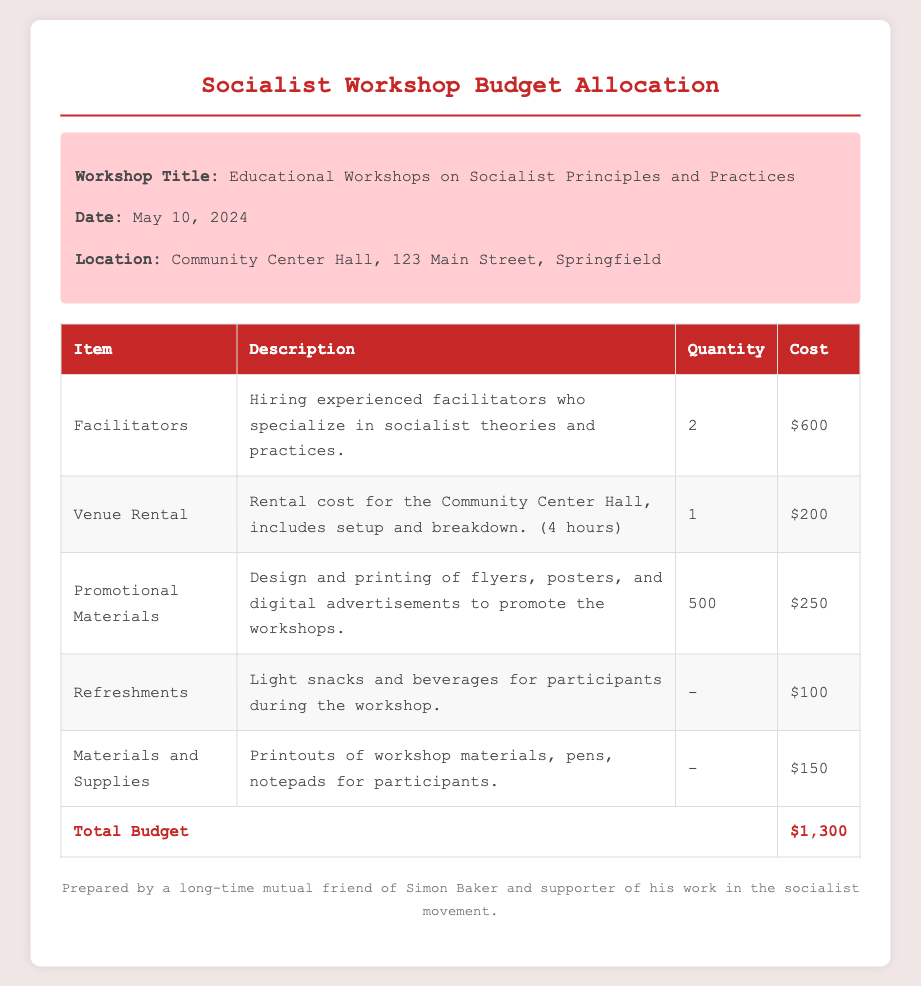What is the workshop title? The workshop title is provided in the document as "Educational Workshops on Socialist Principles and Practices."
Answer: Educational Workshops on Socialist Principles and Practices When is the workshop scheduled? The document states that the workshop is scheduled for May 10, 2024.
Answer: May 10, 2024 How much is allocated for facilitators? The budget shows that $600 is allocated for hiring experienced facilitators.
Answer: $600 What is the total budget for the workshop? The total budget is calculated based on the sum of all budget items, which is indicated as $1,300.
Answer: $1,300 How many promotional materials are planned for design and printing? The document specifies that 500 promotional materials are intended for design and printing.
Answer: 500 What is the venue rental cost? The cost for venue rental as stated in the document is $200.
Answer: $200 What type of refreshments are included in the budget? The document mentions "Light snacks and beverages" for participants.
Answer: Light snacks and beverages Who prepared the budget? The budget is prepared by "a long-time mutual friend of Simon Baker and supporter of his work in the socialist movement."
Answer: a long-time mutual friend of Simon Baker and supporter of his work in the socialist movement What costs are associated with materials and supplies? The document lists the cost for materials and supplies as $150.
Answer: $150 